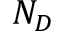Convert formula to latex. <formula><loc_0><loc_0><loc_500><loc_500>N _ { D }</formula> 